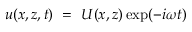Convert formula to latex. <formula><loc_0><loc_0><loc_500><loc_500>u ( x , z , t ) = U ( x , z ) \exp ( - i \omega t )</formula> 